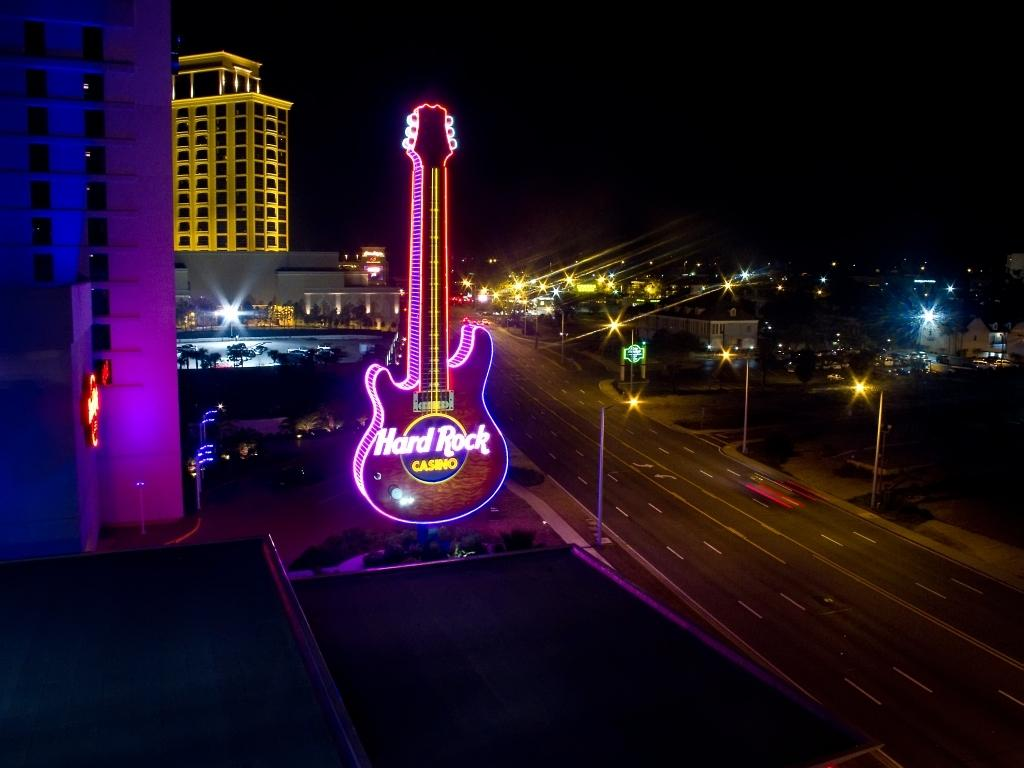Where was the image taken? The image was clicked outside. What can be seen on the left side of the image? There are buildings on the left side of the image. What is located in the middle of the image? There are lights and a road in the middle of the image. What is visible at the top of the image? The sky is visible at the top of the image. What type of silver object can be seen swinging in the image? There is no silver object or swing present in the image. Can you hear the people in the image crying? There is no indication of sound or people crying in the image. 